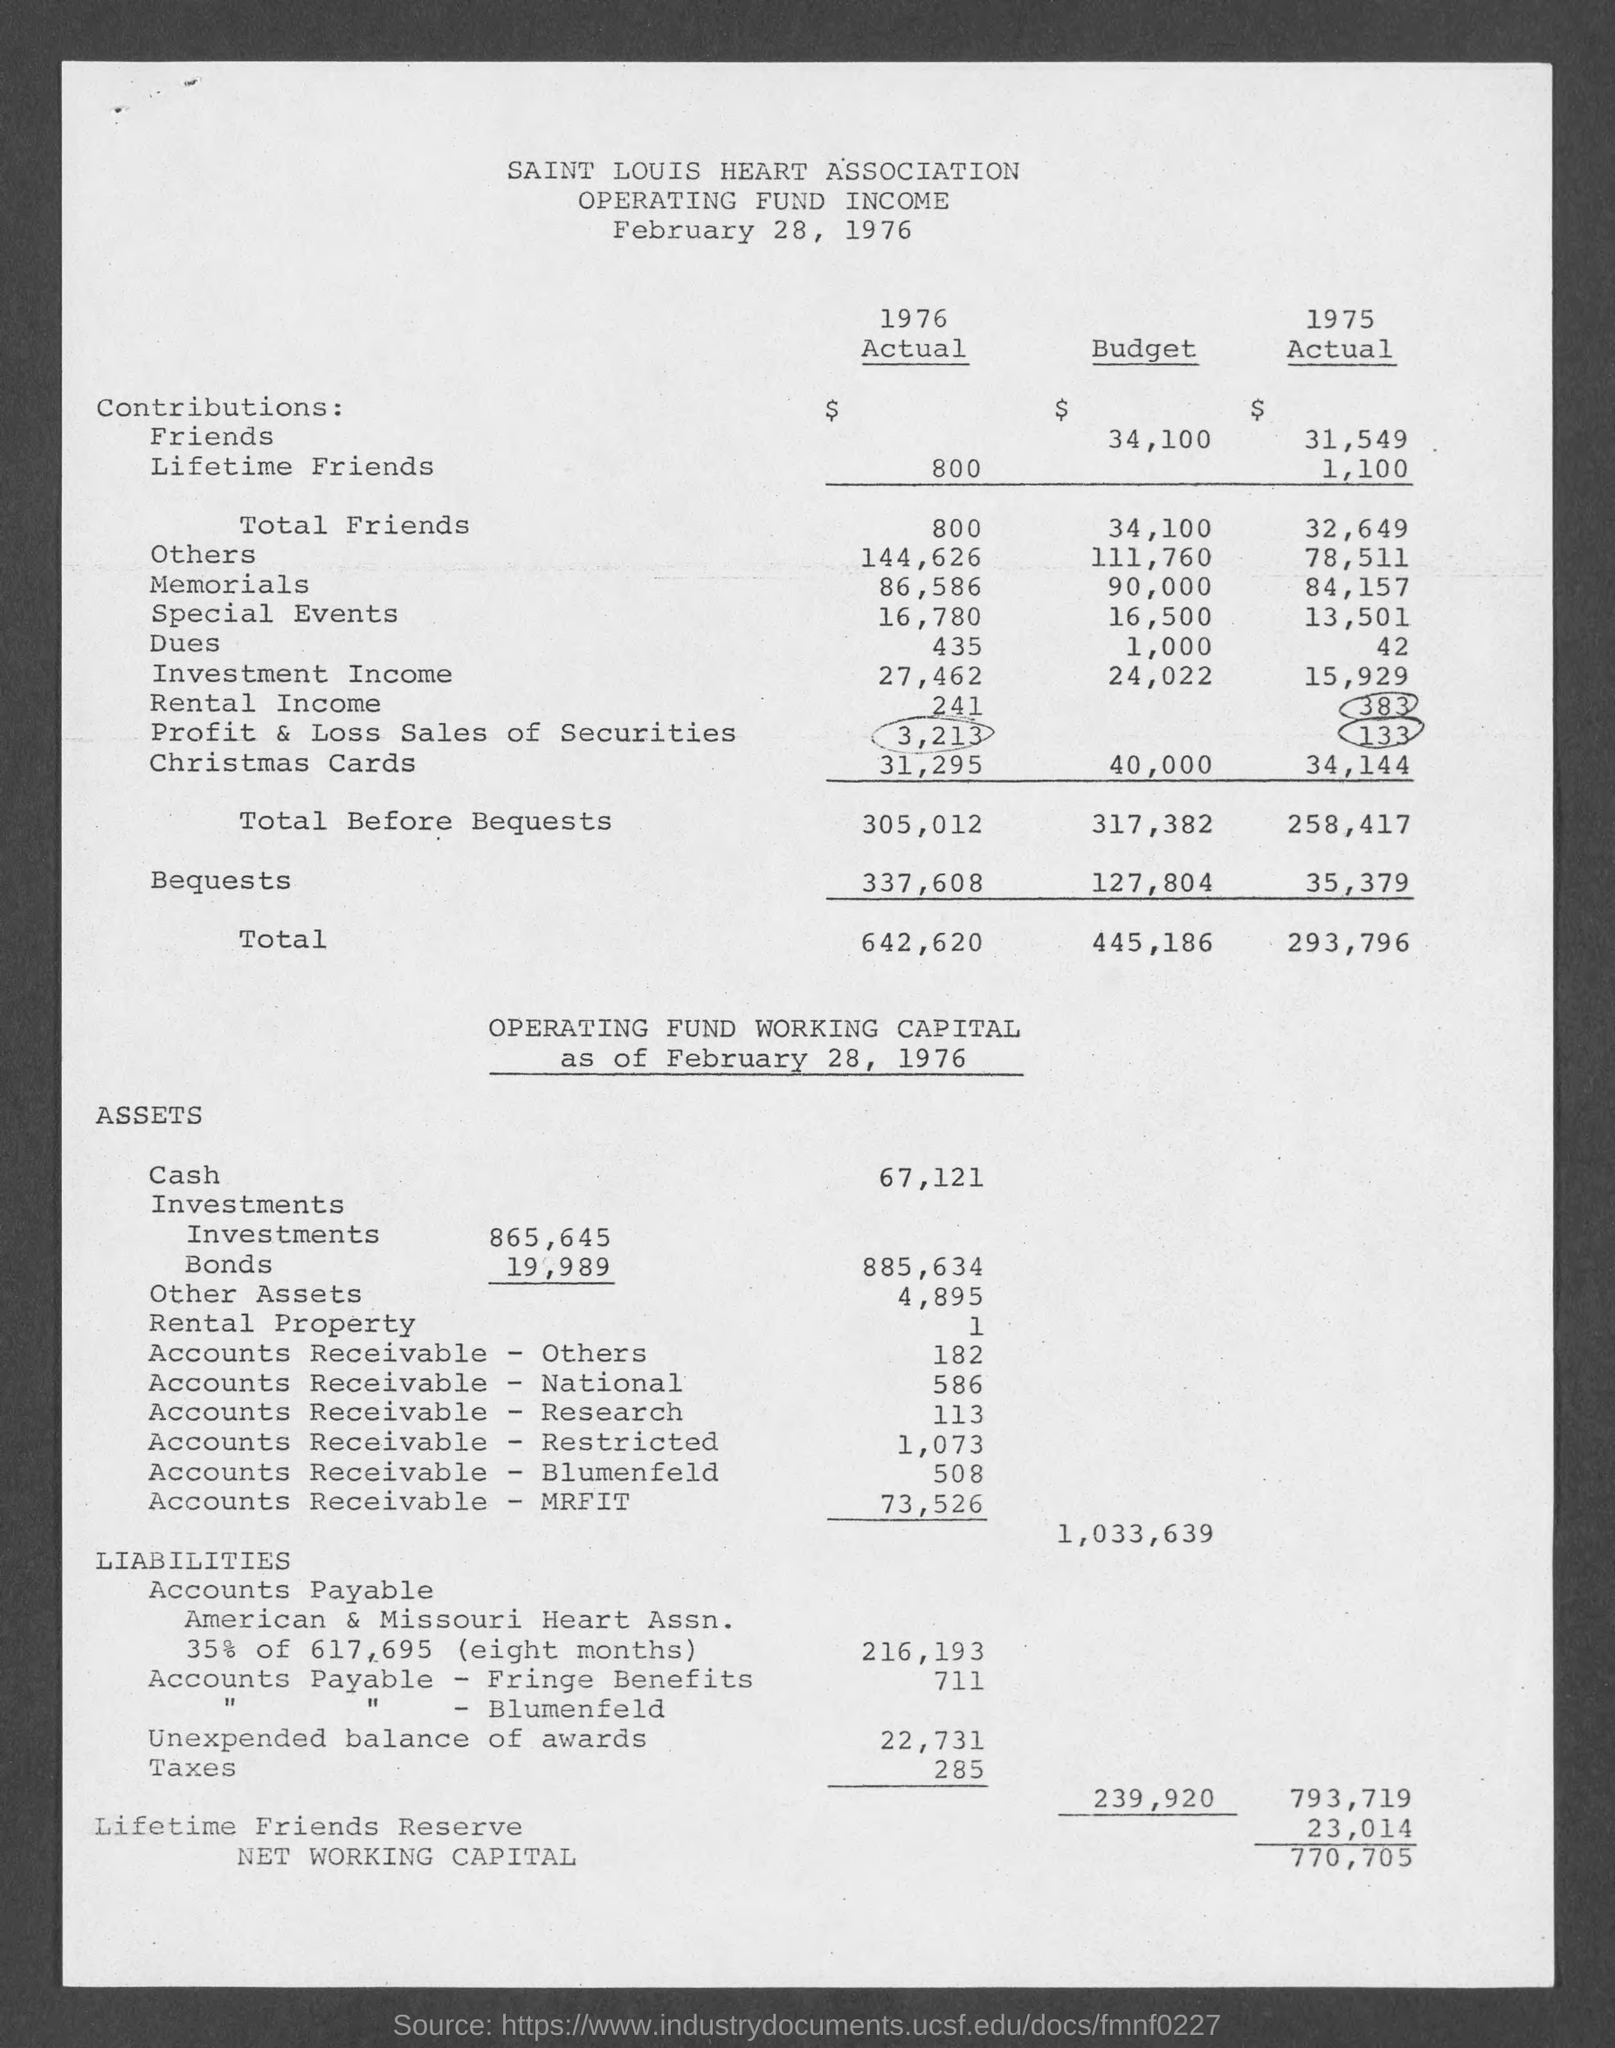Draw attention to some important aspects in this diagram. The Saint Louis Heart Association is mentioned in the document. The document in question has a date of February 28, 1976. 